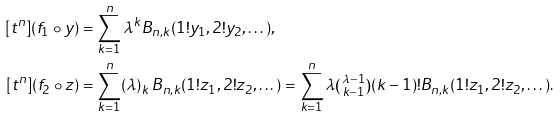Convert formula to latex. <formula><loc_0><loc_0><loc_500><loc_500>[ t ^ { n } ] ( f _ { 1 } \circ y ) & = \sum _ { k = 1 } ^ { n } \lambda ^ { k } B _ { n , k } ( 1 ! y _ { 1 } , 2 ! y _ { 2 } , \dots ) , \\ [ t ^ { n } ] ( f _ { 2 } \circ z ) & = \sum _ { k = 1 } ^ { n } ( \lambda ) _ { k } \, B _ { n , k } ( 1 ! z _ { 1 } , 2 ! z _ { 2 } , \dots ) = \sum _ { k = 1 } ^ { n } \lambda \tbinom { \lambda - 1 } { k - 1 } ( k - 1 ) ! B _ { n , k } ( 1 ! z _ { 1 } , 2 ! z _ { 2 } , \dots ) .</formula> 